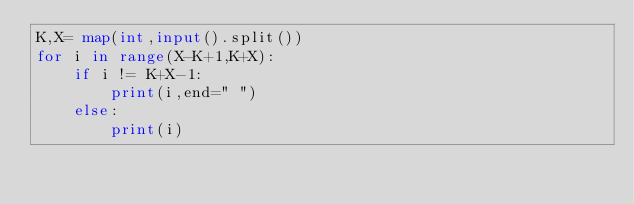Convert code to text. <code><loc_0><loc_0><loc_500><loc_500><_Python_>K,X= map(int,input().split())
for i in range(X-K+1,K+X):
    if i != K+X-1:
        print(i,end=" ")
    else:
        print(i)</code> 